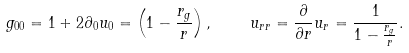Convert formula to latex. <formula><loc_0><loc_0><loc_500><loc_500>g _ { 0 0 } = 1 + 2 \partial _ { 0 } u _ { 0 } = \left ( 1 - \frac { r _ { g } } { r } \right ) , \quad u _ { r r } = \frac { \partial } { \partial r } u _ { r } = \frac { 1 } { 1 - \frac { r _ { g } } { r } } .</formula> 